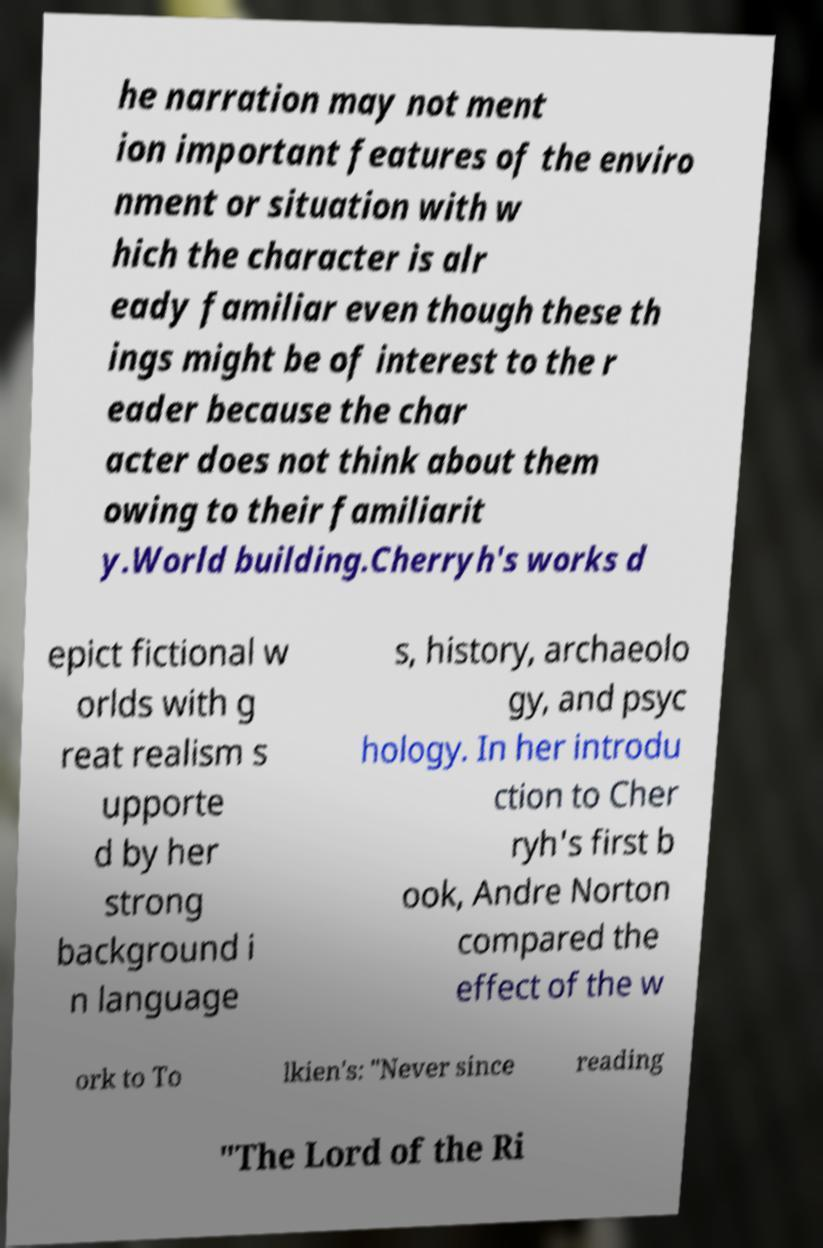Could you extract and type out the text from this image? he narration may not ment ion important features of the enviro nment or situation with w hich the character is alr eady familiar even though these th ings might be of interest to the r eader because the char acter does not think about them owing to their familiarit y.World building.Cherryh's works d epict fictional w orlds with g reat realism s upporte d by her strong background i n language s, history, archaeolo gy, and psyc hology. In her introdu ction to Cher ryh's first b ook, Andre Norton compared the effect of the w ork to To lkien's: "Never since reading "The Lord of the Ri 